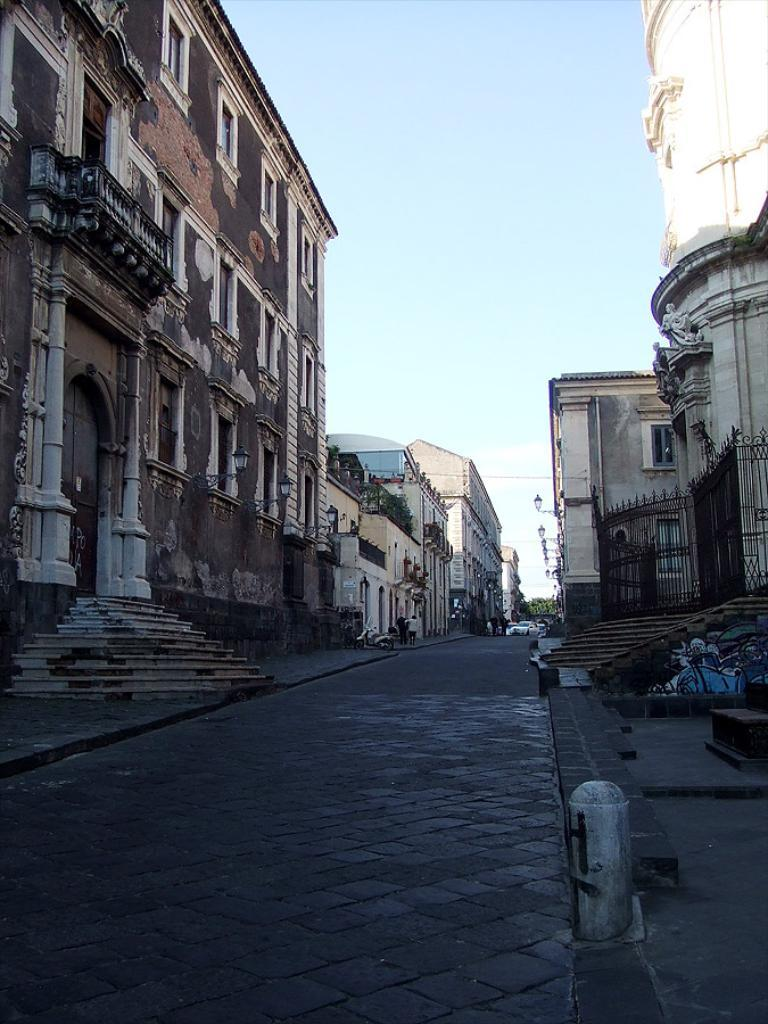What type of structures can be seen in the image in the image? There are buildings in the image. What is located at the bottom of the image? There is a road at the bottom of the image. What is moving along the road in the image? Cars are visible on the road. What can be seen in the background of the image? There is sky visible in the background of the image. Where is the camera located in the image? There is no camera present in the image. Can you see a zebra crossing the road in the image? There is no zebra present in the image. 